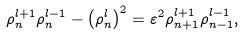<formula> <loc_0><loc_0><loc_500><loc_500>\rho _ { n } ^ { l + 1 } \rho _ { n } ^ { l - 1 } - \left ( \rho _ { n } ^ { l } \right ) ^ { 2 } = \varepsilon ^ { 2 } \rho _ { n + 1 } ^ { l + 1 } \rho _ { n - 1 } ^ { l - 1 } ,</formula> 